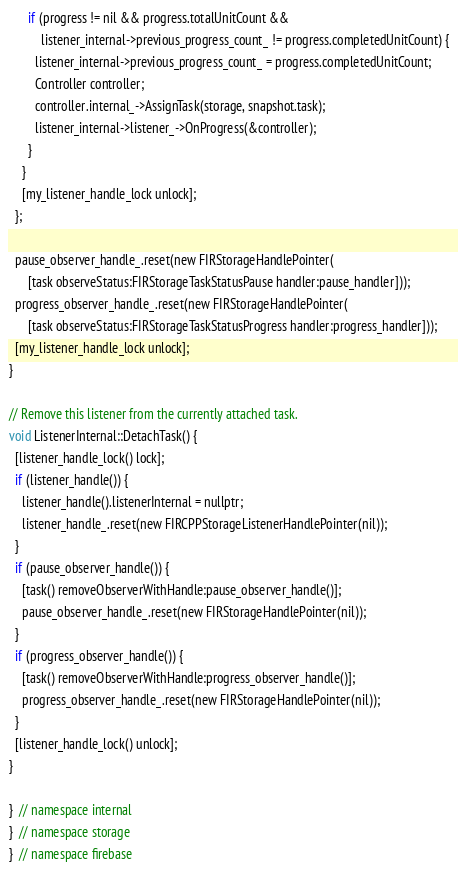<code> <loc_0><loc_0><loc_500><loc_500><_ObjectiveC_>      if (progress != nil && progress.totalUnitCount &&
          listener_internal->previous_progress_count_ != progress.completedUnitCount) {
        listener_internal->previous_progress_count_ = progress.completedUnitCount;
        Controller controller;
        controller.internal_->AssignTask(storage, snapshot.task);
        listener_internal->listener_->OnProgress(&controller);
      }
    }
    [my_listener_handle_lock unlock];
  };

  pause_observer_handle_.reset(new FIRStorageHandlePointer(
      [task observeStatus:FIRStorageTaskStatusPause handler:pause_handler]));
  progress_observer_handle_.reset(new FIRStorageHandlePointer(
      [task observeStatus:FIRStorageTaskStatusProgress handler:progress_handler]));
  [my_listener_handle_lock unlock];
}

// Remove this listener from the currently attached task.
void ListenerInternal::DetachTask() {
  [listener_handle_lock() lock];
  if (listener_handle()) {
    listener_handle().listenerInternal = nullptr;
    listener_handle_.reset(new FIRCPPStorageListenerHandlePointer(nil));
  }
  if (pause_observer_handle()) {
    [task() removeObserverWithHandle:pause_observer_handle()];
    pause_observer_handle_.reset(new FIRStorageHandlePointer(nil));
  }
  if (progress_observer_handle()) {
    [task() removeObserverWithHandle:progress_observer_handle()];
    progress_observer_handle_.reset(new FIRStorageHandlePointer(nil));
  }
  [listener_handle_lock() unlock];
}

}  // namespace internal
}  // namespace storage
}  // namespace firebase
</code> 